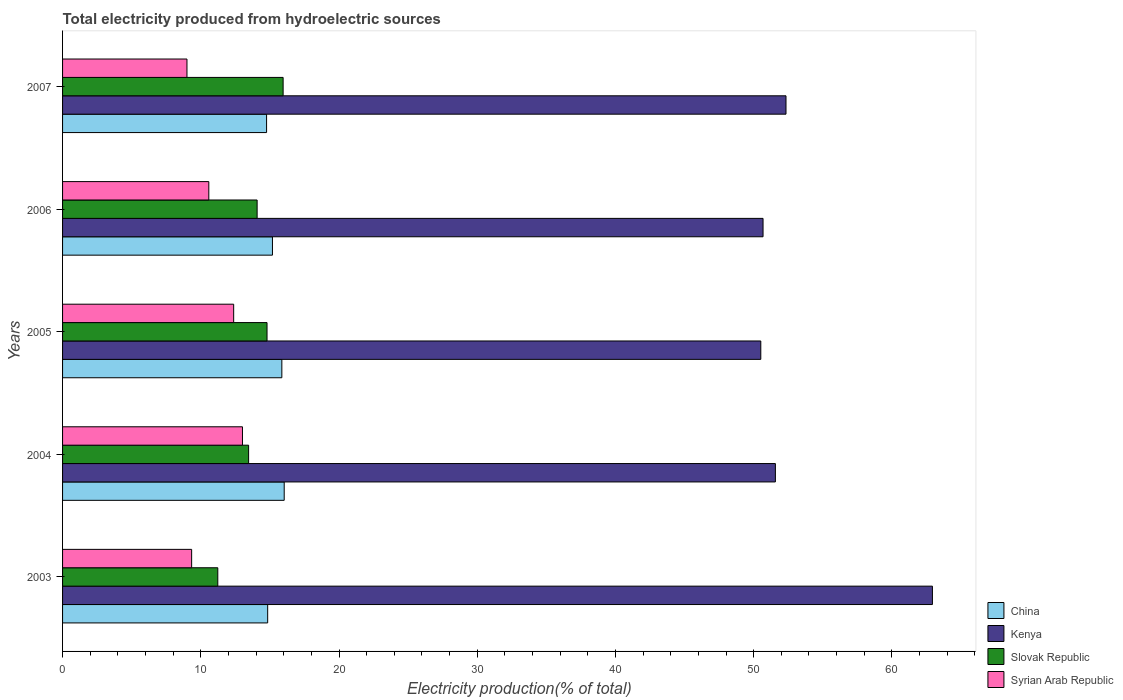How many different coloured bars are there?
Your answer should be compact. 4. How many groups of bars are there?
Provide a succinct answer. 5. How many bars are there on the 4th tick from the top?
Offer a terse response. 4. How many bars are there on the 2nd tick from the bottom?
Your answer should be compact. 4. In how many cases, is the number of bars for a given year not equal to the number of legend labels?
Your response must be concise. 0. What is the total electricity produced in Slovak Republic in 2005?
Offer a terse response. 14.79. Across all years, what is the maximum total electricity produced in China?
Make the answer very short. 16.04. Across all years, what is the minimum total electricity produced in Slovak Republic?
Give a very brief answer. 11.23. What is the total total electricity produced in Slovak Republic in the graph?
Provide a short and direct response. 69.52. What is the difference between the total electricity produced in Syrian Arab Republic in 2006 and that in 2007?
Provide a short and direct response. 1.58. What is the difference between the total electricity produced in Slovak Republic in 2007 and the total electricity produced in Kenya in 2003?
Make the answer very short. -46.98. What is the average total electricity produced in Slovak Republic per year?
Provide a succinct answer. 13.9. In the year 2007, what is the difference between the total electricity produced in Kenya and total electricity produced in Syrian Arab Republic?
Provide a short and direct response. 43.34. In how many years, is the total electricity produced in Kenya greater than 2 %?
Offer a terse response. 5. What is the ratio of the total electricity produced in China in 2006 to that in 2007?
Provide a short and direct response. 1.03. Is the difference between the total electricity produced in Kenya in 2003 and 2006 greater than the difference between the total electricity produced in Syrian Arab Republic in 2003 and 2006?
Your answer should be very brief. Yes. What is the difference between the highest and the second highest total electricity produced in China?
Offer a terse response. 0.17. What is the difference between the highest and the lowest total electricity produced in Slovak Republic?
Your answer should be compact. 4.73. In how many years, is the total electricity produced in Syrian Arab Republic greater than the average total electricity produced in Syrian Arab Republic taken over all years?
Ensure brevity in your answer.  2. Is the sum of the total electricity produced in Syrian Arab Republic in 2005 and 2006 greater than the maximum total electricity produced in Kenya across all years?
Ensure brevity in your answer.  No. What does the 3rd bar from the top in 2004 represents?
Your answer should be compact. Kenya. What does the 4th bar from the bottom in 2004 represents?
Provide a succinct answer. Syrian Arab Republic. How many bars are there?
Your response must be concise. 20. Are all the bars in the graph horizontal?
Ensure brevity in your answer.  Yes. What is the difference between two consecutive major ticks on the X-axis?
Offer a very short reply. 10. Does the graph contain any zero values?
Your answer should be compact. No. Does the graph contain grids?
Your answer should be very brief. No. What is the title of the graph?
Offer a terse response. Total electricity produced from hydroelectric sources. Does "St. Martin (French part)" appear as one of the legend labels in the graph?
Your response must be concise. No. What is the label or title of the X-axis?
Make the answer very short. Electricity production(% of total). What is the label or title of the Y-axis?
Your response must be concise. Years. What is the Electricity production(% of total) in China in 2003?
Provide a succinct answer. 14.84. What is the Electricity production(% of total) in Kenya in 2003?
Ensure brevity in your answer.  62.93. What is the Electricity production(% of total) of Slovak Republic in 2003?
Offer a terse response. 11.23. What is the Electricity production(% of total) in Syrian Arab Republic in 2003?
Keep it short and to the point. 9.34. What is the Electricity production(% of total) of China in 2004?
Give a very brief answer. 16.04. What is the Electricity production(% of total) of Kenya in 2004?
Ensure brevity in your answer.  51.57. What is the Electricity production(% of total) of Slovak Republic in 2004?
Keep it short and to the point. 13.46. What is the Electricity production(% of total) of Syrian Arab Republic in 2004?
Provide a short and direct response. 13.02. What is the Electricity production(% of total) in China in 2005?
Ensure brevity in your answer.  15.86. What is the Electricity production(% of total) in Kenya in 2005?
Offer a terse response. 50.52. What is the Electricity production(% of total) in Slovak Republic in 2005?
Make the answer very short. 14.79. What is the Electricity production(% of total) in Syrian Arab Republic in 2005?
Your answer should be compact. 12.38. What is the Electricity production(% of total) in China in 2006?
Make the answer very short. 15.19. What is the Electricity production(% of total) of Kenya in 2006?
Your response must be concise. 50.68. What is the Electricity production(% of total) in Slovak Republic in 2006?
Make the answer very short. 14.08. What is the Electricity production(% of total) of Syrian Arab Republic in 2006?
Keep it short and to the point. 10.58. What is the Electricity production(% of total) of China in 2007?
Keep it short and to the point. 14.76. What is the Electricity production(% of total) in Kenya in 2007?
Ensure brevity in your answer.  52.34. What is the Electricity production(% of total) in Slovak Republic in 2007?
Keep it short and to the point. 15.96. What is the Electricity production(% of total) in Syrian Arab Republic in 2007?
Ensure brevity in your answer.  9. Across all years, what is the maximum Electricity production(% of total) in China?
Ensure brevity in your answer.  16.04. Across all years, what is the maximum Electricity production(% of total) of Kenya?
Offer a very short reply. 62.93. Across all years, what is the maximum Electricity production(% of total) in Slovak Republic?
Make the answer very short. 15.96. Across all years, what is the maximum Electricity production(% of total) of Syrian Arab Republic?
Your answer should be compact. 13.02. Across all years, what is the minimum Electricity production(% of total) of China?
Provide a short and direct response. 14.76. Across all years, what is the minimum Electricity production(% of total) of Kenya?
Your answer should be compact. 50.52. Across all years, what is the minimum Electricity production(% of total) of Slovak Republic?
Keep it short and to the point. 11.23. Across all years, what is the minimum Electricity production(% of total) in Syrian Arab Republic?
Make the answer very short. 9. What is the total Electricity production(% of total) of China in the graph?
Ensure brevity in your answer.  76.69. What is the total Electricity production(% of total) of Kenya in the graph?
Offer a terse response. 268.05. What is the total Electricity production(% of total) in Slovak Republic in the graph?
Offer a very short reply. 69.52. What is the total Electricity production(% of total) in Syrian Arab Republic in the graph?
Provide a short and direct response. 54.32. What is the difference between the Electricity production(% of total) in China in 2003 and that in 2004?
Your answer should be compact. -1.2. What is the difference between the Electricity production(% of total) in Kenya in 2003 and that in 2004?
Provide a short and direct response. 11.36. What is the difference between the Electricity production(% of total) in Slovak Republic in 2003 and that in 2004?
Make the answer very short. -2.23. What is the difference between the Electricity production(% of total) of Syrian Arab Republic in 2003 and that in 2004?
Your answer should be compact. -3.68. What is the difference between the Electricity production(% of total) in China in 2003 and that in 2005?
Offer a very short reply. -1.03. What is the difference between the Electricity production(% of total) of Kenya in 2003 and that in 2005?
Provide a short and direct response. 12.42. What is the difference between the Electricity production(% of total) in Slovak Republic in 2003 and that in 2005?
Ensure brevity in your answer.  -3.56. What is the difference between the Electricity production(% of total) in Syrian Arab Republic in 2003 and that in 2005?
Give a very brief answer. -3.04. What is the difference between the Electricity production(% of total) of China in 2003 and that in 2006?
Keep it short and to the point. -0.35. What is the difference between the Electricity production(% of total) in Kenya in 2003 and that in 2006?
Provide a succinct answer. 12.25. What is the difference between the Electricity production(% of total) in Slovak Republic in 2003 and that in 2006?
Provide a succinct answer. -2.85. What is the difference between the Electricity production(% of total) in Syrian Arab Republic in 2003 and that in 2006?
Provide a short and direct response. -1.24. What is the difference between the Electricity production(% of total) in China in 2003 and that in 2007?
Make the answer very short. 0.08. What is the difference between the Electricity production(% of total) of Kenya in 2003 and that in 2007?
Provide a short and direct response. 10.59. What is the difference between the Electricity production(% of total) of Slovak Republic in 2003 and that in 2007?
Your answer should be very brief. -4.73. What is the difference between the Electricity production(% of total) in Syrian Arab Republic in 2003 and that in 2007?
Your answer should be very brief. 0.34. What is the difference between the Electricity production(% of total) of China in 2004 and that in 2005?
Your answer should be compact. 0.17. What is the difference between the Electricity production(% of total) of Kenya in 2004 and that in 2005?
Your answer should be very brief. 1.06. What is the difference between the Electricity production(% of total) in Slovak Republic in 2004 and that in 2005?
Your answer should be compact. -1.33. What is the difference between the Electricity production(% of total) of Syrian Arab Republic in 2004 and that in 2005?
Your answer should be compact. 0.64. What is the difference between the Electricity production(% of total) of China in 2004 and that in 2006?
Make the answer very short. 0.85. What is the difference between the Electricity production(% of total) in Kenya in 2004 and that in 2006?
Provide a short and direct response. 0.89. What is the difference between the Electricity production(% of total) in Slovak Republic in 2004 and that in 2006?
Provide a succinct answer. -0.62. What is the difference between the Electricity production(% of total) of Syrian Arab Republic in 2004 and that in 2006?
Your response must be concise. 2.43. What is the difference between the Electricity production(% of total) of China in 2004 and that in 2007?
Give a very brief answer. 1.27. What is the difference between the Electricity production(% of total) in Kenya in 2004 and that in 2007?
Offer a very short reply. -0.77. What is the difference between the Electricity production(% of total) of Slovak Republic in 2004 and that in 2007?
Provide a short and direct response. -2.5. What is the difference between the Electricity production(% of total) in Syrian Arab Republic in 2004 and that in 2007?
Make the answer very short. 4.01. What is the difference between the Electricity production(% of total) in China in 2005 and that in 2006?
Provide a succinct answer. 0.68. What is the difference between the Electricity production(% of total) of Kenya in 2005 and that in 2006?
Your answer should be very brief. -0.16. What is the difference between the Electricity production(% of total) of Slovak Republic in 2005 and that in 2006?
Your response must be concise. 0.72. What is the difference between the Electricity production(% of total) of Syrian Arab Republic in 2005 and that in 2006?
Ensure brevity in your answer.  1.8. What is the difference between the Electricity production(% of total) in China in 2005 and that in 2007?
Provide a short and direct response. 1.1. What is the difference between the Electricity production(% of total) of Kenya in 2005 and that in 2007?
Offer a very short reply. -1.82. What is the difference between the Electricity production(% of total) in Slovak Republic in 2005 and that in 2007?
Your answer should be very brief. -1.16. What is the difference between the Electricity production(% of total) of Syrian Arab Republic in 2005 and that in 2007?
Provide a succinct answer. 3.38. What is the difference between the Electricity production(% of total) in China in 2006 and that in 2007?
Keep it short and to the point. 0.42. What is the difference between the Electricity production(% of total) in Kenya in 2006 and that in 2007?
Offer a very short reply. -1.66. What is the difference between the Electricity production(% of total) in Slovak Republic in 2006 and that in 2007?
Give a very brief answer. -1.88. What is the difference between the Electricity production(% of total) of Syrian Arab Republic in 2006 and that in 2007?
Your answer should be very brief. 1.58. What is the difference between the Electricity production(% of total) of China in 2003 and the Electricity production(% of total) of Kenya in 2004?
Ensure brevity in your answer.  -36.73. What is the difference between the Electricity production(% of total) of China in 2003 and the Electricity production(% of total) of Slovak Republic in 2004?
Provide a short and direct response. 1.38. What is the difference between the Electricity production(% of total) of China in 2003 and the Electricity production(% of total) of Syrian Arab Republic in 2004?
Your answer should be very brief. 1.82. What is the difference between the Electricity production(% of total) of Kenya in 2003 and the Electricity production(% of total) of Slovak Republic in 2004?
Offer a terse response. 49.47. What is the difference between the Electricity production(% of total) in Kenya in 2003 and the Electricity production(% of total) in Syrian Arab Republic in 2004?
Make the answer very short. 49.92. What is the difference between the Electricity production(% of total) of Slovak Republic in 2003 and the Electricity production(% of total) of Syrian Arab Republic in 2004?
Provide a succinct answer. -1.78. What is the difference between the Electricity production(% of total) of China in 2003 and the Electricity production(% of total) of Kenya in 2005?
Your answer should be very brief. -35.68. What is the difference between the Electricity production(% of total) of China in 2003 and the Electricity production(% of total) of Slovak Republic in 2005?
Offer a terse response. 0.05. What is the difference between the Electricity production(% of total) in China in 2003 and the Electricity production(% of total) in Syrian Arab Republic in 2005?
Offer a very short reply. 2.46. What is the difference between the Electricity production(% of total) of Kenya in 2003 and the Electricity production(% of total) of Slovak Republic in 2005?
Give a very brief answer. 48.14. What is the difference between the Electricity production(% of total) in Kenya in 2003 and the Electricity production(% of total) in Syrian Arab Republic in 2005?
Give a very brief answer. 50.55. What is the difference between the Electricity production(% of total) of Slovak Republic in 2003 and the Electricity production(% of total) of Syrian Arab Republic in 2005?
Your answer should be compact. -1.15. What is the difference between the Electricity production(% of total) in China in 2003 and the Electricity production(% of total) in Kenya in 2006?
Ensure brevity in your answer.  -35.84. What is the difference between the Electricity production(% of total) of China in 2003 and the Electricity production(% of total) of Slovak Republic in 2006?
Your answer should be compact. 0.76. What is the difference between the Electricity production(% of total) in China in 2003 and the Electricity production(% of total) in Syrian Arab Republic in 2006?
Offer a terse response. 4.26. What is the difference between the Electricity production(% of total) of Kenya in 2003 and the Electricity production(% of total) of Slovak Republic in 2006?
Keep it short and to the point. 48.86. What is the difference between the Electricity production(% of total) in Kenya in 2003 and the Electricity production(% of total) in Syrian Arab Republic in 2006?
Your answer should be very brief. 52.35. What is the difference between the Electricity production(% of total) in Slovak Republic in 2003 and the Electricity production(% of total) in Syrian Arab Republic in 2006?
Ensure brevity in your answer.  0.65. What is the difference between the Electricity production(% of total) in China in 2003 and the Electricity production(% of total) in Kenya in 2007?
Provide a succinct answer. -37.5. What is the difference between the Electricity production(% of total) of China in 2003 and the Electricity production(% of total) of Slovak Republic in 2007?
Offer a very short reply. -1.12. What is the difference between the Electricity production(% of total) in China in 2003 and the Electricity production(% of total) in Syrian Arab Republic in 2007?
Offer a very short reply. 5.84. What is the difference between the Electricity production(% of total) in Kenya in 2003 and the Electricity production(% of total) in Slovak Republic in 2007?
Your answer should be compact. 46.98. What is the difference between the Electricity production(% of total) in Kenya in 2003 and the Electricity production(% of total) in Syrian Arab Republic in 2007?
Offer a terse response. 53.93. What is the difference between the Electricity production(% of total) in Slovak Republic in 2003 and the Electricity production(% of total) in Syrian Arab Republic in 2007?
Make the answer very short. 2.23. What is the difference between the Electricity production(% of total) in China in 2004 and the Electricity production(% of total) in Kenya in 2005?
Offer a very short reply. -34.48. What is the difference between the Electricity production(% of total) of China in 2004 and the Electricity production(% of total) of Slovak Republic in 2005?
Your response must be concise. 1.24. What is the difference between the Electricity production(% of total) in China in 2004 and the Electricity production(% of total) in Syrian Arab Republic in 2005?
Offer a very short reply. 3.66. What is the difference between the Electricity production(% of total) in Kenya in 2004 and the Electricity production(% of total) in Slovak Republic in 2005?
Your answer should be very brief. 36.78. What is the difference between the Electricity production(% of total) in Kenya in 2004 and the Electricity production(% of total) in Syrian Arab Republic in 2005?
Make the answer very short. 39.19. What is the difference between the Electricity production(% of total) of Slovak Republic in 2004 and the Electricity production(% of total) of Syrian Arab Republic in 2005?
Provide a short and direct response. 1.08. What is the difference between the Electricity production(% of total) in China in 2004 and the Electricity production(% of total) in Kenya in 2006?
Ensure brevity in your answer.  -34.64. What is the difference between the Electricity production(% of total) in China in 2004 and the Electricity production(% of total) in Slovak Republic in 2006?
Keep it short and to the point. 1.96. What is the difference between the Electricity production(% of total) in China in 2004 and the Electricity production(% of total) in Syrian Arab Republic in 2006?
Offer a terse response. 5.45. What is the difference between the Electricity production(% of total) in Kenya in 2004 and the Electricity production(% of total) in Slovak Republic in 2006?
Provide a succinct answer. 37.5. What is the difference between the Electricity production(% of total) in Kenya in 2004 and the Electricity production(% of total) in Syrian Arab Republic in 2006?
Offer a terse response. 40.99. What is the difference between the Electricity production(% of total) of Slovak Republic in 2004 and the Electricity production(% of total) of Syrian Arab Republic in 2006?
Offer a terse response. 2.88. What is the difference between the Electricity production(% of total) in China in 2004 and the Electricity production(% of total) in Kenya in 2007?
Provide a short and direct response. -36.31. What is the difference between the Electricity production(% of total) in China in 2004 and the Electricity production(% of total) in Slovak Republic in 2007?
Keep it short and to the point. 0.08. What is the difference between the Electricity production(% of total) in China in 2004 and the Electricity production(% of total) in Syrian Arab Republic in 2007?
Provide a succinct answer. 7.04. What is the difference between the Electricity production(% of total) in Kenya in 2004 and the Electricity production(% of total) in Slovak Republic in 2007?
Your response must be concise. 35.61. What is the difference between the Electricity production(% of total) of Kenya in 2004 and the Electricity production(% of total) of Syrian Arab Republic in 2007?
Provide a short and direct response. 42.57. What is the difference between the Electricity production(% of total) in Slovak Republic in 2004 and the Electricity production(% of total) in Syrian Arab Republic in 2007?
Your response must be concise. 4.46. What is the difference between the Electricity production(% of total) in China in 2005 and the Electricity production(% of total) in Kenya in 2006?
Provide a succinct answer. -34.82. What is the difference between the Electricity production(% of total) in China in 2005 and the Electricity production(% of total) in Slovak Republic in 2006?
Your answer should be compact. 1.79. What is the difference between the Electricity production(% of total) of China in 2005 and the Electricity production(% of total) of Syrian Arab Republic in 2006?
Your answer should be very brief. 5.28. What is the difference between the Electricity production(% of total) in Kenya in 2005 and the Electricity production(% of total) in Slovak Republic in 2006?
Offer a terse response. 36.44. What is the difference between the Electricity production(% of total) of Kenya in 2005 and the Electricity production(% of total) of Syrian Arab Republic in 2006?
Give a very brief answer. 39.94. What is the difference between the Electricity production(% of total) in Slovak Republic in 2005 and the Electricity production(% of total) in Syrian Arab Republic in 2006?
Make the answer very short. 4.21. What is the difference between the Electricity production(% of total) of China in 2005 and the Electricity production(% of total) of Kenya in 2007?
Your answer should be compact. -36.48. What is the difference between the Electricity production(% of total) of China in 2005 and the Electricity production(% of total) of Slovak Republic in 2007?
Give a very brief answer. -0.09. What is the difference between the Electricity production(% of total) in China in 2005 and the Electricity production(% of total) in Syrian Arab Republic in 2007?
Your answer should be compact. 6.86. What is the difference between the Electricity production(% of total) in Kenya in 2005 and the Electricity production(% of total) in Slovak Republic in 2007?
Your answer should be compact. 34.56. What is the difference between the Electricity production(% of total) in Kenya in 2005 and the Electricity production(% of total) in Syrian Arab Republic in 2007?
Offer a very short reply. 41.52. What is the difference between the Electricity production(% of total) in Slovak Republic in 2005 and the Electricity production(% of total) in Syrian Arab Republic in 2007?
Provide a succinct answer. 5.79. What is the difference between the Electricity production(% of total) of China in 2006 and the Electricity production(% of total) of Kenya in 2007?
Keep it short and to the point. -37.16. What is the difference between the Electricity production(% of total) in China in 2006 and the Electricity production(% of total) in Slovak Republic in 2007?
Provide a short and direct response. -0.77. What is the difference between the Electricity production(% of total) of China in 2006 and the Electricity production(% of total) of Syrian Arab Republic in 2007?
Keep it short and to the point. 6.18. What is the difference between the Electricity production(% of total) in Kenya in 2006 and the Electricity production(% of total) in Slovak Republic in 2007?
Your response must be concise. 34.72. What is the difference between the Electricity production(% of total) of Kenya in 2006 and the Electricity production(% of total) of Syrian Arab Republic in 2007?
Provide a succinct answer. 41.68. What is the difference between the Electricity production(% of total) of Slovak Republic in 2006 and the Electricity production(% of total) of Syrian Arab Republic in 2007?
Provide a short and direct response. 5.08. What is the average Electricity production(% of total) of China per year?
Your answer should be very brief. 15.34. What is the average Electricity production(% of total) in Kenya per year?
Your answer should be compact. 53.61. What is the average Electricity production(% of total) of Slovak Republic per year?
Your answer should be compact. 13.9. What is the average Electricity production(% of total) of Syrian Arab Republic per year?
Offer a terse response. 10.86. In the year 2003, what is the difference between the Electricity production(% of total) in China and Electricity production(% of total) in Kenya?
Your answer should be compact. -48.09. In the year 2003, what is the difference between the Electricity production(% of total) of China and Electricity production(% of total) of Slovak Republic?
Provide a short and direct response. 3.61. In the year 2003, what is the difference between the Electricity production(% of total) in China and Electricity production(% of total) in Syrian Arab Republic?
Ensure brevity in your answer.  5.5. In the year 2003, what is the difference between the Electricity production(% of total) of Kenya and Electricity production(% of total) of Slovak Republic?
Keep it short and to the point. 51.7. In the year 2003, what is the difference between the Electricity production(% of total) in Kenya and Electricity production(% of total) in Syrian Arab Republic?
Make the answer very short. 53.6. In the year 2003, what is the difference between the Electricity production(% of total) in Slovak Republic and Electricity production(% of total) in Syrian Arab Republic?
Your answer should be very brief. 1.89. In the year 2004, what is the difference between the Electricity production(% of total) of China and Electricity production(% of total) of Kenya?
Your answer should be very brief. -35.54. In the year 2004, what is the difference between the Electricity production(% of total) in China and Electricity production(% of total) in Slovak Republic?
Make the answer very short. 2.58. In the year 2004, what is the difference between the Electricity production(% of total) in China and Electricity production(% of total) in Syrian Arab Republic?
Offer a very short reply. 3.02. In the year 2004, what is the difference between the Electricity production(% of total) of Kenya and Electricity production(% of total) of Slovak Republic?
Your answer should be very brief. 38.11. In the year 2004, what is the difference between the Electricity production(% of total) of Kenya and Electricity production(% of total) of Syrian Arab Republic?
Give a very brief answer. 38.56. In the year 2004, what is the difference between the Electricity production(% of total) in Slovak Republic and Electricity production(% of total) in Syrian Arab Republic?
Give a very brief answer. 0.44. In the year 2005, what is the difference between the Electricity production(% of total) in China and Electricity production(% of total) in Kenya?
Your answer should be compact. -34.65. In the year 2005, what is the difference between the Electricity production(% of total) of China and Electricity production(% of total) of Slovak Republic?
Provide a succinct answer. 1.07. In the year 2005, what is the difference between the Electricity production(% of total) of China and Electricity production(% of total) of Syrian Arab Republic?
Ensure brevity in your answer.  3.48. In the year 2005, what is the difference between the Electricity production(% of total) of Kenya and Electricity production(% of total) of Slovak Republic?
Keep it short and to the point. 35.72. In the year 2005, what is the difference between the Electricity production(% of total) of Kenya and Electricity production(% of total) of Syrian Arab Republic?
Provide a short and direct response. 38.14. In the year 2005, what is the difference between the Electricity production(% of total) in Slovak Republic and Electricity production(% of total) in Syrian Arab Republic?
Your answer should be very brief. 2.41. In the year 2006, what is the difference between the Electricity production(% of total) of China and Electricity production(% of total) of Kenya?
Ensure brevity in your answer.  -35.5. In the year 2006, what is the difference between the Electricity production(% of total) of China and Electricity production(% of total) of Slovak Republic?
Offer a very short reply. 1.11. In the year 2006, what is the difference between the Electricity production(% of total) in China and Electricity production(% of total) in Syrian Arab Republic?
Offer a terse response. 4.6. In the year 2006, what is the difference between the Electricity production(% of total) of Kenya and Electricity production(% of total) of Slovak Republic?
Give a very brief answer. 36.6. In the year 2006, what is the difference between the Electricity production(% of total) of Kenya and Electricity production(% of total) of Syrian Arab Republic?
Give a very brief answer. 40.1. In the year 2006, what is the difference between the Electricity production(% of total) of Slovak Republic and Electricity production(% of total) of Syrian Arab Republic?
Your answer should be compact. 3.5. In the year 2007, what is the difference between the Electricity production(% of total) of China and Electricity production(% of total) of Kenya?
Your answer should be very brief. -37.58. In the year 2007, what is the difference between the Electricity production(% of total) in China and Electricity production(% of total) in Slovak Republic?
Offer a terse response. -1.2. In the year 2007, what is the difference between the Electricity production(% of total) of China and Electricity production(% of total) of Syrian Arab Republic?
Ensure brevity in your answer.  5.76. In the year 2007, what is the difference between the Electricity production(% of total) in Kenya and Electricity production(% of total) in Slovak Republic?
Offer a terse response. 36.38. In the year 2007, what is the difference between the Electricity production(% of total) in Kenya and Electricity production(% of total) in Syrian Arab Republic?
Provide a short and direct response. 43.34. In the year 2007, what is the difference between the Electricity production(% of total) in Slovak Republic and Electricity production(% of total) in Syrian Arab Republic?
Ensure brevity in your answer.  6.96. What is the ratio of the Electricity production(% of total) in China in 2003 to that in 2004?
Offer a very short reply. 0.93. What is the ratio of the Electricity production(% of total) in Kenya in 2003 to that in 2004?
Provide a short and direct response. 1.22. What is the ratio of the Electricity production(% of total) of Slovak Republic in 2003 to that in 2004?
Keep it short and to the point. 0.83. What is the ratio of the Electricity production(% of total) in Syrian Arab Republic in 2003 to that in 2004?
Your response must be concise. 0.72. What is the ratio of the Electricity production(% of total) in China in 2003 to that in 2005?
Make the answer very short. 0.94. What is the ratio of the Electricity production(% of total) of Kenya in 2003 to that in 2005?
Make the answer very short. 1.25. What is the ratio of the Electricity production(% of total) in Slovak Republic in 2003 to that in 2005?
Your response must be concise. 0.76. What is the ratio of the Electricity production(% of total) in Syrian Arab Republic in 2003 to that in 2005?
Give a very brief answer. 0.75. What is the ratio of the Electricity production(% of total) in China in 2003 to that in 2006?
Your response must be concise. 0.98. What is the ratio of the Electricity production(% of total) in Kenya in 2003 to that in 2006?
Your response must be concise. 1.24. What is the ratio of the Electricity production(% of total) in Slovak Republic in 2003 to that in 2006?
Make the answer very short. 0.8. What is the ratio of the Electricity production(% of total) in Syrian Arab Republic in 2003 to that in 2006?
Your answer should be very brief. 0.88. What is the ratio of the Electricity production(% of total) of Kenya in 2003 to that in 2007?
Provide a succinct answer. 1.2. What is the ratio of the Electricity production(% of total) of Slovak Republic in 2003 to that in 2007?
Offer a terse response. 0.7. What is the ratio of the Electricity production(% of total) in Syrian Arab Republic in 2003 to that in 2007?
Offer a terse response. 1.04. What is the ratio of the Electricity production(% of total) in China in 2004 to that in 2005?
Your response must be concise. 1.01. What is the ratio of the Electricity production(% of total) in Kenya in 2004 to that in 2005?
Make the answer very short. 1.02. What is the ratio of the Electricity production(% of total) of Slovak Republic in 2004 to that in 2005?
Ensure brevity in your answer.  0.91. What is the ratio of the Electricity production(% of total) of Syrian Arab Republic in 2004 to that in 2005?
Provide a succinct answer. 1.05. What is the ratio of the Electricity production(% of total) of China in 2004 to that in 2006?
Give a very brief answer. 1.06. What is the ratio of the Electricity production(% of total) in Kenya in 2004 to that in 2006?
Make the answer very short. 1.02. What is the ratio of the Electricity production(% of total) in Slovak Republic in 2004 to that in 2006?
Give a very brief answer. 0.96. What is the ratio of the Electricity production(% of total) of Syrian Arab Republic in 2004 to that in 2006?
Make the answer very short. 1.23. What is the ratio of the Electricity production(% of total) of China in 2004 to that in 2007?
Make the answer very short. 1.09. What is the ratio of the Electricity production(% of total) in Slovak Republic in 2004 to that in 2007?
Ensure brevity in your answer.  0.84. What is the ratio of the Electricity production(% of total) in Syrian Arab Republic in 2004 to that in 2007?
Make the answer very short. 1.45. What is the ratio of the Electricity production(% of total) of China in 2005 to that in 2006?
Make the answer very short. 1.04. What is the ratio of the Electricity production(% of total) of Kenya in 2005 to that in 2006?
Provide a succinct answer. 1. What is the ratio of the Electricity production(% of total) in Slovak Republic in 2005 to that in 2006?
Offer a very short reply. 1.05. What is the ratio of the Electricity production(% of total) in Syrian Arab Republic in 2005 to that in 2006?
Your answer should be very brief. 1.17. What is the ratio of the Electricity production(% of total) in China in 2005 to that in 2007?
Give a very brief answer. 1.07. What is the ratio of the Electricity production(% of total) in Kenya in 2005 to that in 2007?
Your answer should be very brief. 0.97. What is the ratio of the Electricity production(% of total) of Slovak Republic in 2005 to that in 2007?
Your answer should be very brief. 0.93. What is the ratio of the Electricity production(% of total) of Syrian Arab Republic in 2005 to that in 2007?
Provide a short and direct response. 1.38. What is the ratio of the Electricity production(% of total) of China in 2006 to that in 2007?
Ensure brevity in your answer.  1.03. What is the ratio of the Electricity production(% of total) of Kenya in 2006 to that in 2007?
Provide a succinct answer. 0.97. What is the ratio of the Electricity production(% of total) of Slovak Republic in 2006 to that in 2007?
Your answer should be very brief. 0.88. What is the ratio of the Electricity production(% of total) in Syrian Arab Republic in 2006 to that in 2007?
Your response must be concise. 1.18. What is the difference between the highest and the second highest Electricity production(% of total) in China?
Your answer should be compact. 0.17. What is the difference between the highest and the second highest Electricity production(% of total) in Kenya?
Your answer should be compact. 10.59. What is the difference between the highest and the second highest Electricity production(% of total) in Slovak Republic?
Give a very brief answer. 1.16. What is the difference between the highest and the second highest Electricity production(% of total) in Syrian Arab Republic?
Provide a short and direct response. 0.64. What is the difference between the highest and the lowest Electricity production(% of total) in China?
Provide a short and direct response. 1.27. What is the difference between the highest and the lowest Electricity production(% of total) in Kenya?
Make the answer very short. 12.42. What is the difference between the highest and the lowest Electricity production(% of total) of Slovak Republic?
Make the answer very short. 4.73. What is the difference between the highest and the lowest Electricity production(% of total) of Syrian Arab Republic?
Your response must be concise. 4.01. 